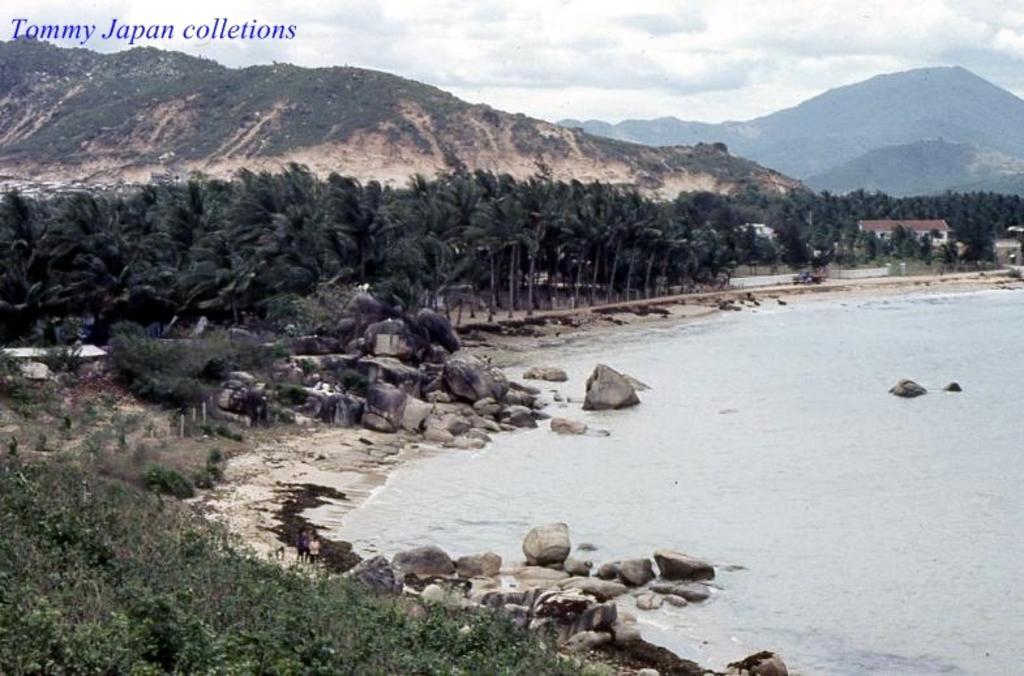Can you describe this image briefly? In this picture we can observe some trees and rocks. We can observe some text on the left side. There is an ocean on the right side. In the background there are hills and a sky with some clouds. 